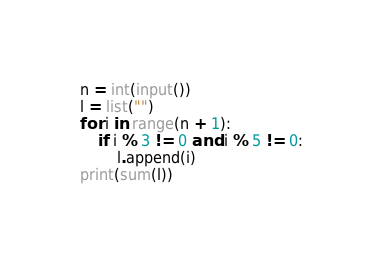<code> <loc_0><loc_0><loc_500><loc_500><_Python_>n = int(input())
l = list("")
for i in range(n + 1):
    if i % 3 != 0 and i % 5 != 0:
        l.append(i)
print(sum(l))
</code> 